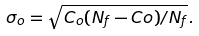Convert formula to latex. <formula><loc_0><loc_0><loc_500><loc_500>\sigma _ { o } = \sqrt { C _ { o } ( N _ { f } - C o ) / N _ { f } } .</formula> 